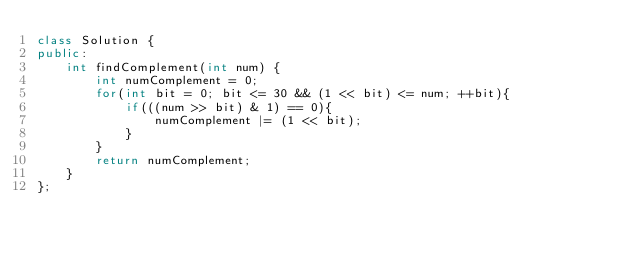<code> <loc_0><loc_0><loc_500><loc_500><_C++_>class Solution {
public:
    int findComplement(int num) {
        int numComplement = 0;
        for(int bit = 0; bit <= 30 && (1 << bit) <= num; ++bit){
            if(((num >> bit) & 1) == 0){
                numComplement |= (1 << bit);
            }
        }
        return numComplement;
    }
};</code> 